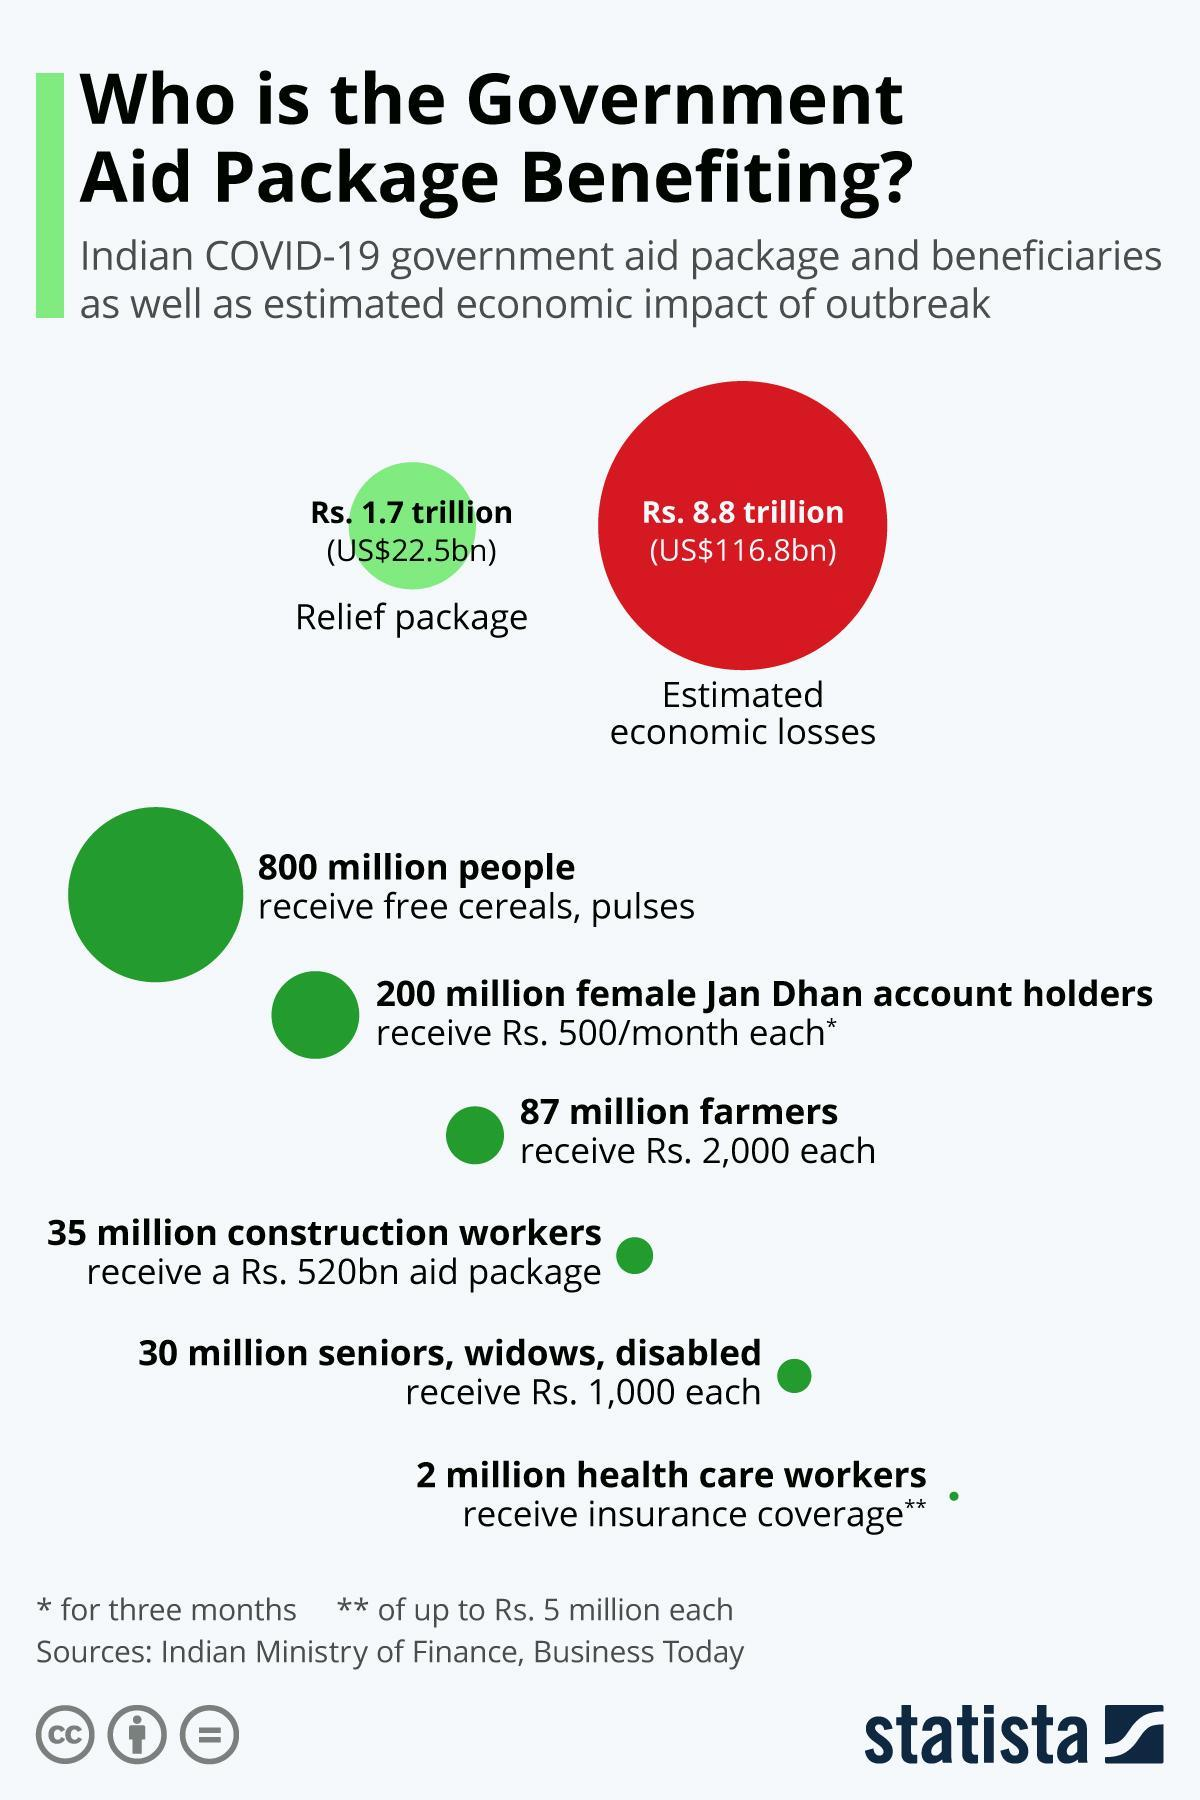Who receives rupees 2000 each?
Answer the question with a short phrase. Farmers How many people receive free cereals and pulses? 800 million What is the estimated economic loss in rupees? 8.8 trillion 